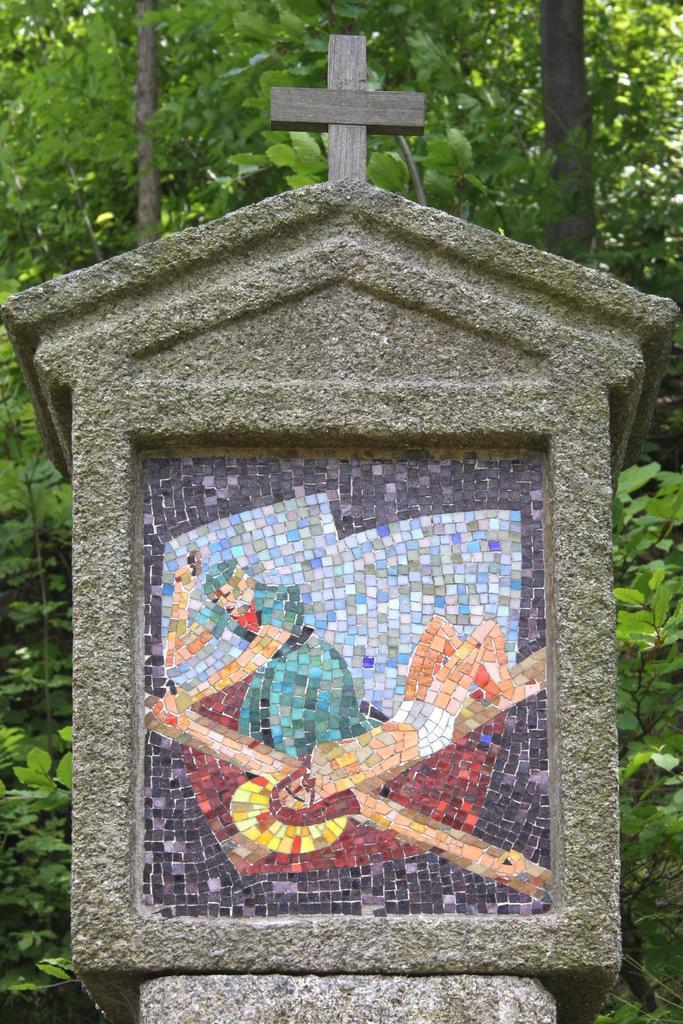In one or two sentences, can you explain what this image depicts? In this image we can see there is a memorable stone. In the background there are trees and plants.  